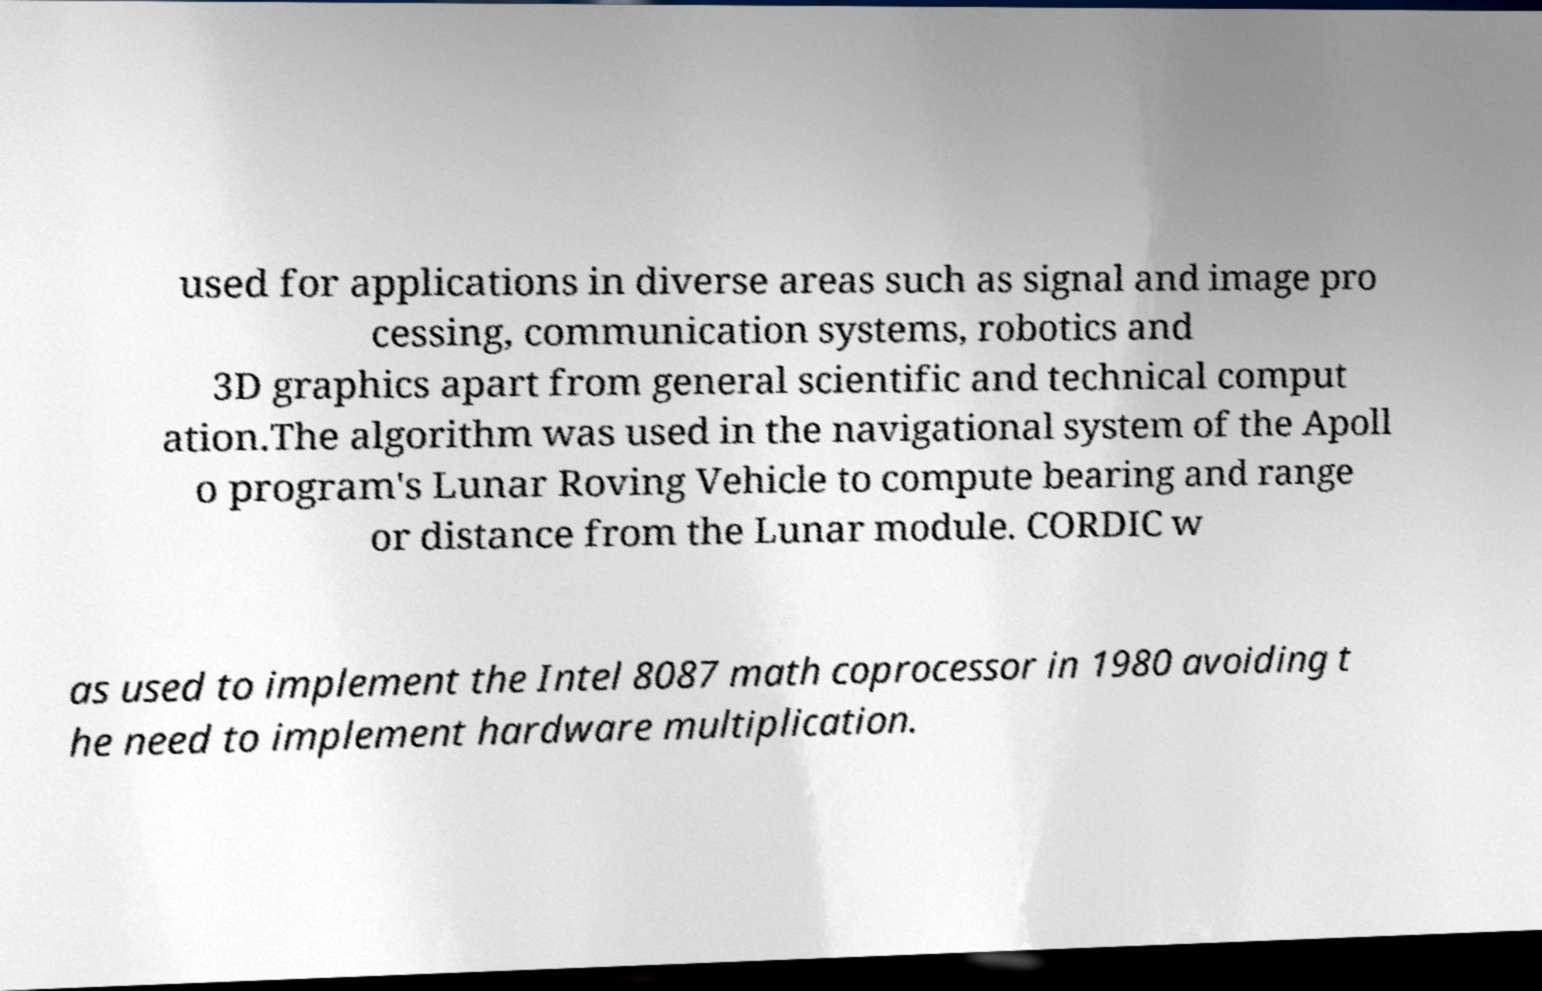There's text embedded in this image that I need extracted. Can you transcribe it verbatim? used for applications in diverse areas such as signal and image pro cessing, communication systems, robotics and 3D graphics apart from general scientific and technical comput ation.The algorithm was used in the navigational system of the Apoll o program's Lunar Roving Vehicle to compute bearing and range or distance from the Lunar module. CORDIC w as used to implement the Intel 8087 math coprocessor in 1980 avoiding t he need to implement hardware multiplication. 